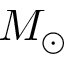Convert formula to latex. <formula><loc_0><loc_0><loc_500><loc_500>M _ { \odot }</formula> 